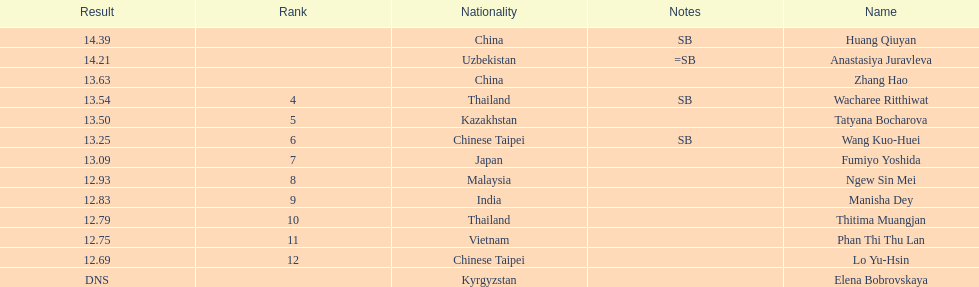What was the average result of the top three jumpers? 14.08. 